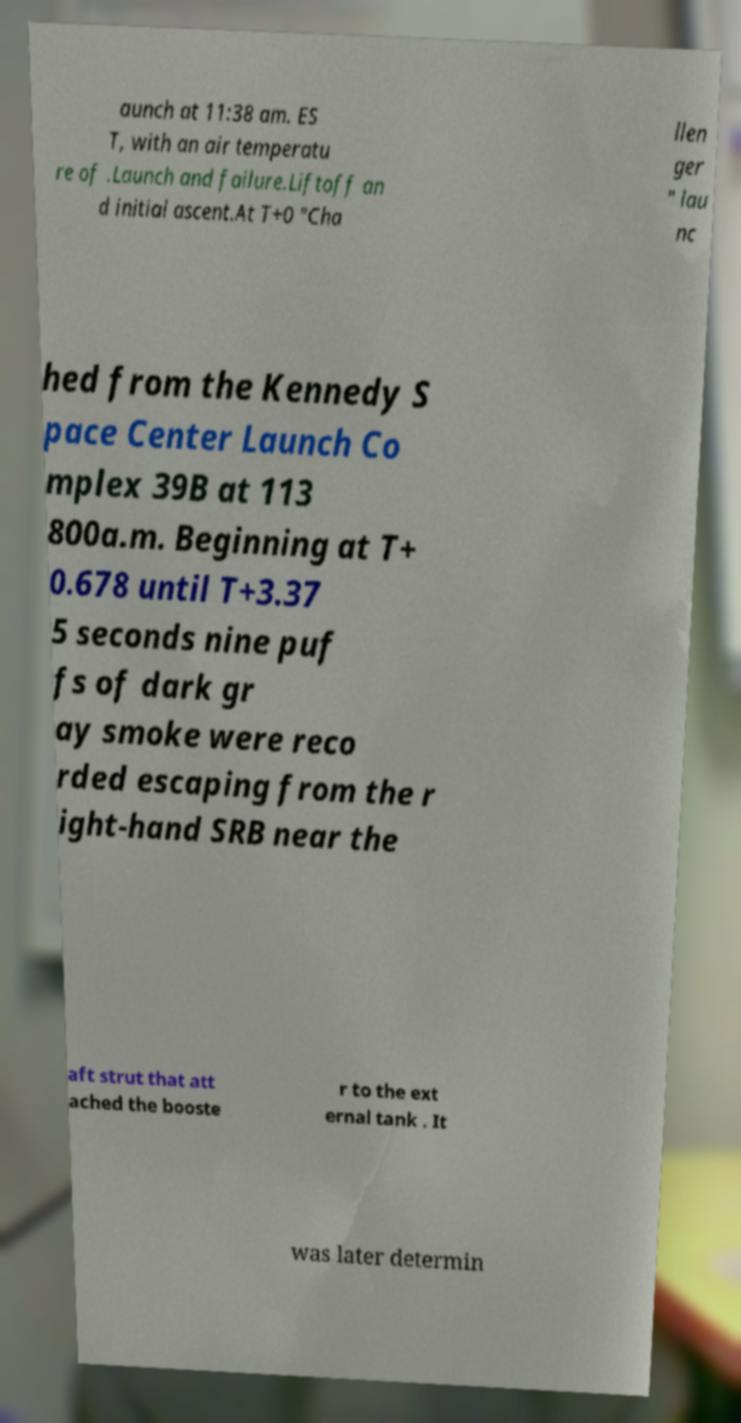Could you assist in decoding the text presented in this image and type it out clearly? aunch at 11:38 am. ES T, with an air temperatu re of .Launch and failure.Liftoff an d initial ascent.At T+0 "Cha llen ger " lau nc hed from the Kennedy S pace Center Launch Co mplex 39B at 113 800a.m. Beginning at T+ 0.678 until T+3.37 5 seconds nine puf fs of dark gr ay smoke were reco rded escaping from the r ight-hand SRB near the aft strut that att ached the booste r to the ext ernal tank . It was later determin 